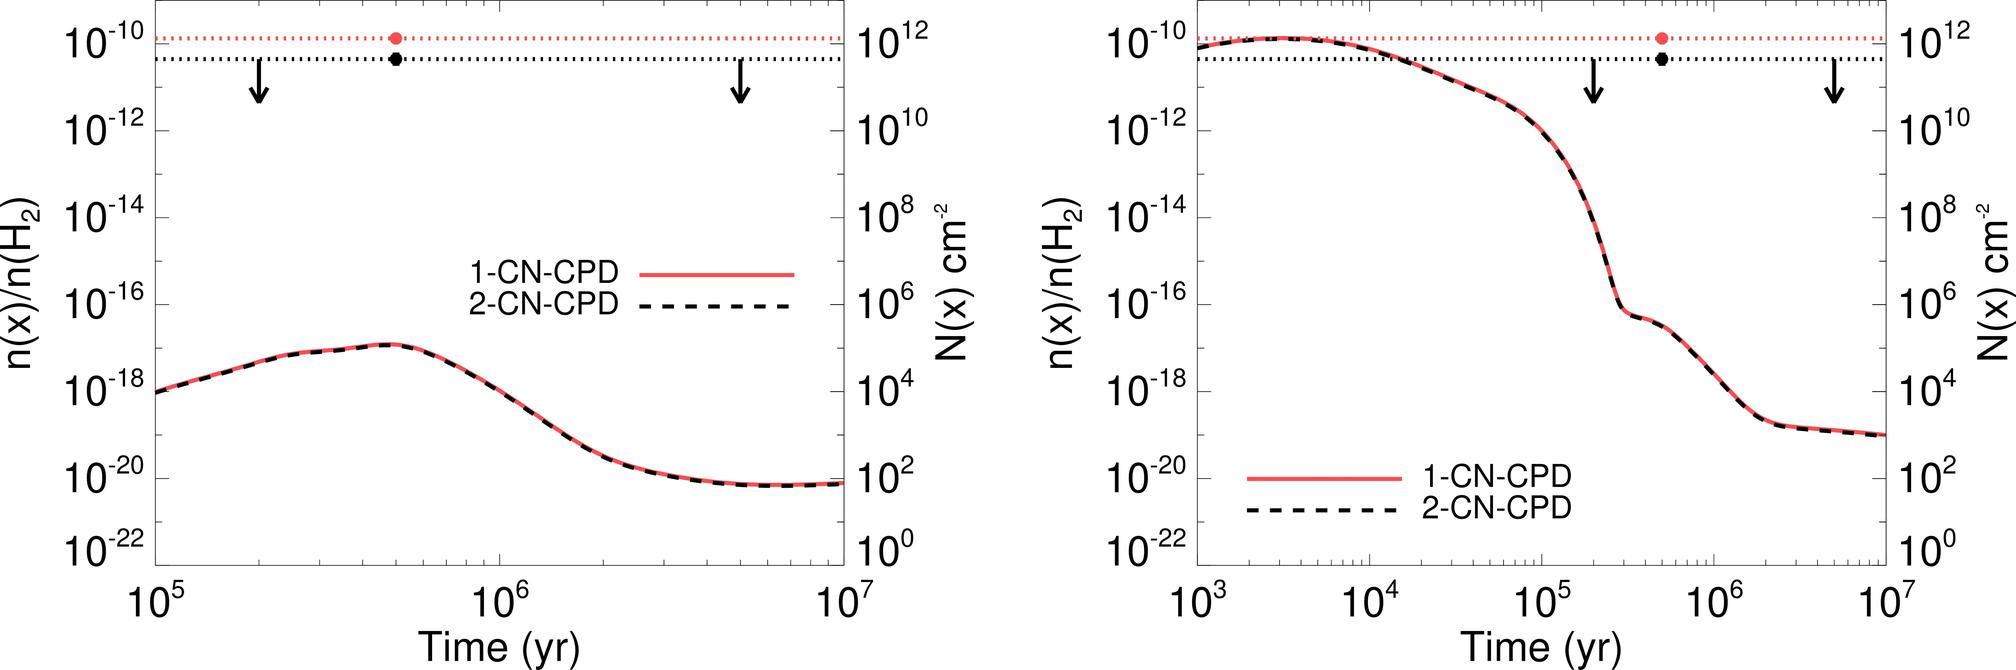Why are there two y-axes with different scales on these graphs? The use of dual y-axes with different scales allows for simultaneous display and comparison of two related datasets with substantially different numerical ranges. It enables the viewer to assess the trends of each dataset more clearly without one series dominating the visual representation due to its scale. 